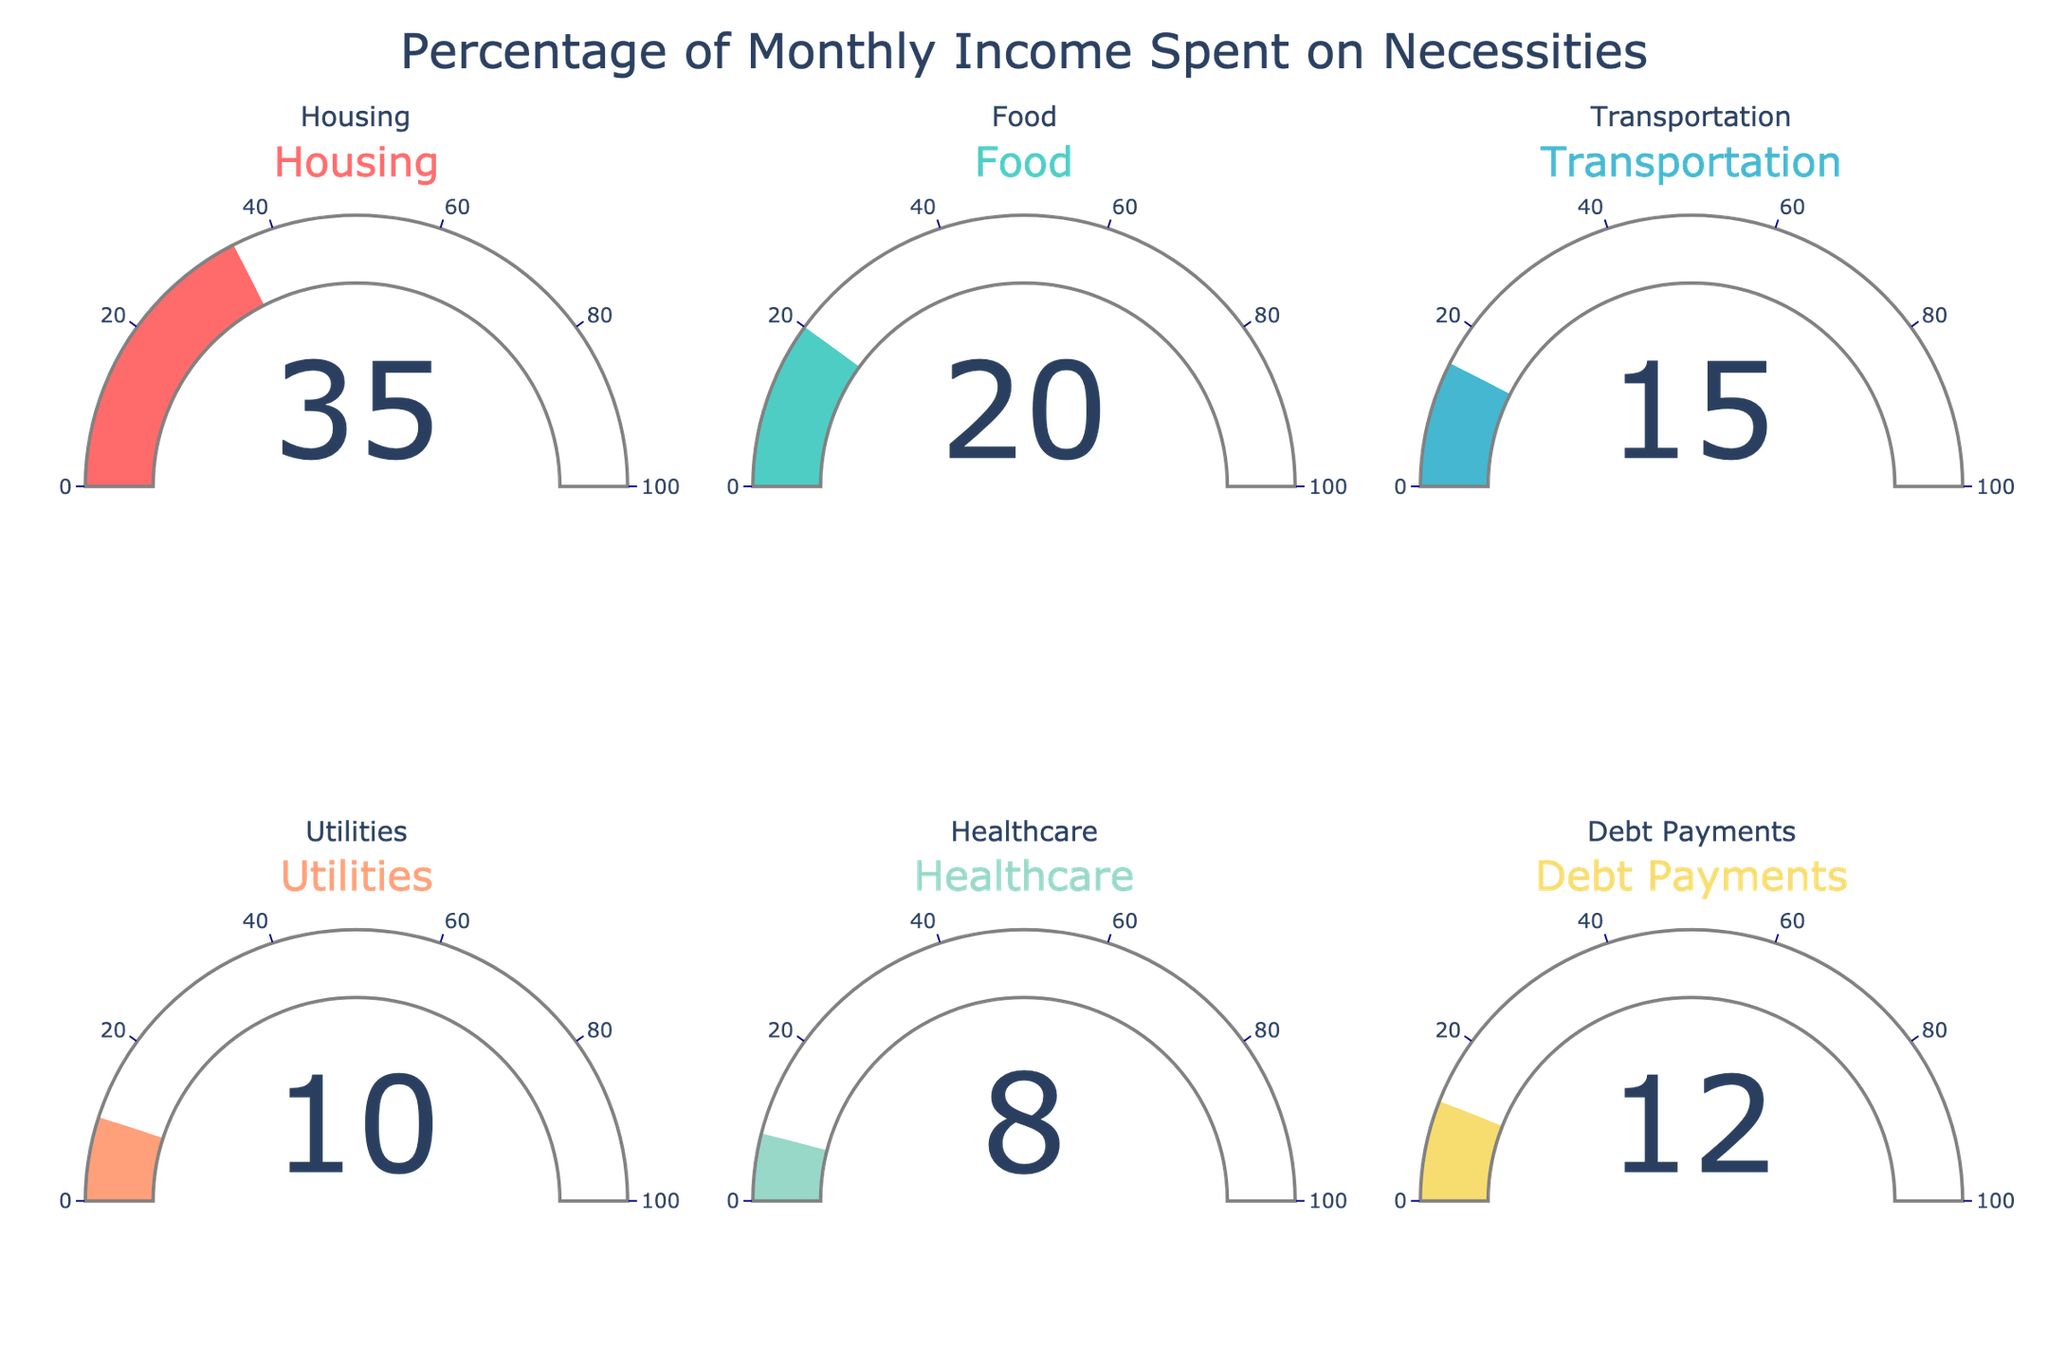What percentage of monthly income is spent on Housing? The gauge chart for Housing shows a needle pointing to the value on the scale, with the percentage displayed inside the gauge.
Answer: 35 What category has the lowest percentage of monthly income spent? Observe the gauges and focus on the value displayed in each one. The lowest value displayed is for Healthcare.
Answer: Healthcare What is the total percentage of monthly income spent on Food and Transportation? Sum the percentages shown in the Food and Transportation gauges. Food is 20% and Transportation is 15%, so the total is 20 + 15.
Answer: 35 Which category has a higher percentage: Utilities or Debt Payments? Compare the percentages shown in the gauges for Utilities and Debt Payments. Utilities shows 10% and Debt Payments shows 12%.
Answer: Debt Payments What is the average percentage of monthly income spent on the given categories? Sum all the percentages shown in the gauges (35 + 20 + 15 + 10 + 8 + 12) and divide by the number of categories (6). The sum is 100, so the average is 100 / 6.
Answer: 16.67 Which category uses more than 30% of the monthly income? Check the values shown on the gauges and identify the category with a value greater than 30%. Only Housing shows a value greater than 30%.
Answer: Housing By how much does the percentage of monthly income spent on Housing exceed that of Healthcare? Subtract the percentage of Healthcare (8%) from Housing (35%). 35 - 8 is the difference.
Answer: 27 What percentage of monthly income is spent on non-Housing categories? Subtract the Housing percentage (35%) from the total (100%). 100 - 35 = 65.
Answer: 65 What is the median percentage of monthly income spent on the given categories? Arrange the percentages in ascending order (8, 10, 12, 15, 20, 35). The median is the average of the two middle numbers since there are six values: (12 + 15) / 2.
Answer: 13.5 How does the gauge color of Food compare to that of Healthcare? The gauge for Food is in a teal/greenish color and the gauge for Healthcare is in a light green color. Compare these two colors.
Answer: Different 